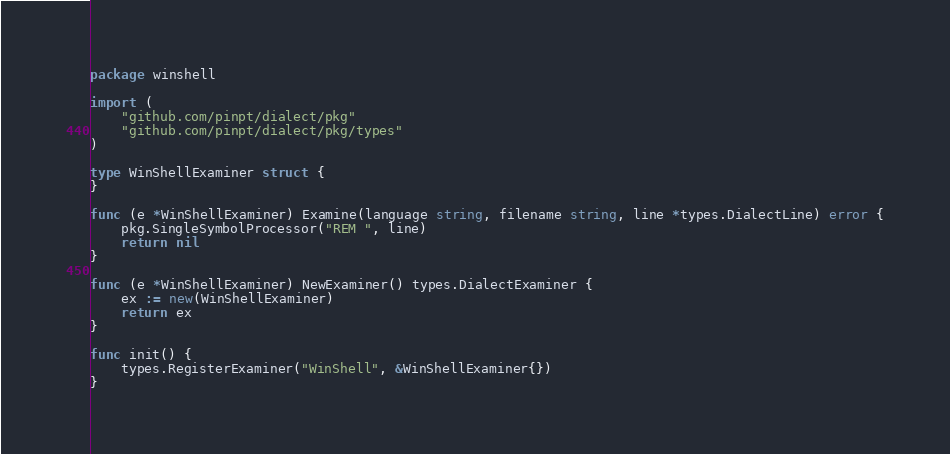<code> <loc_0><loc_0><loc_500><loc_500><_Go_>package winshell

import (
	"github.com/pinpt/dialect/pkg"
	"github.com/pinpt/dialect/pkg/types"
)

type WinShellExaminer struct {
}

func (e *WinShellExaminer) Examine(language string, filename string, line *types.DialectLine) error {
	pkg.SingleSymbolProcessor("REM ", line)
	return nil
}

func (e *WinShellExaminer) NewExaminer() types.DialectExaminer {
	ex := new(WinShellExaminer)
	return ex
}

func init() {
	types.RegisterExaminer("WinShell", &WinShellExaminer{})
}
</code> 